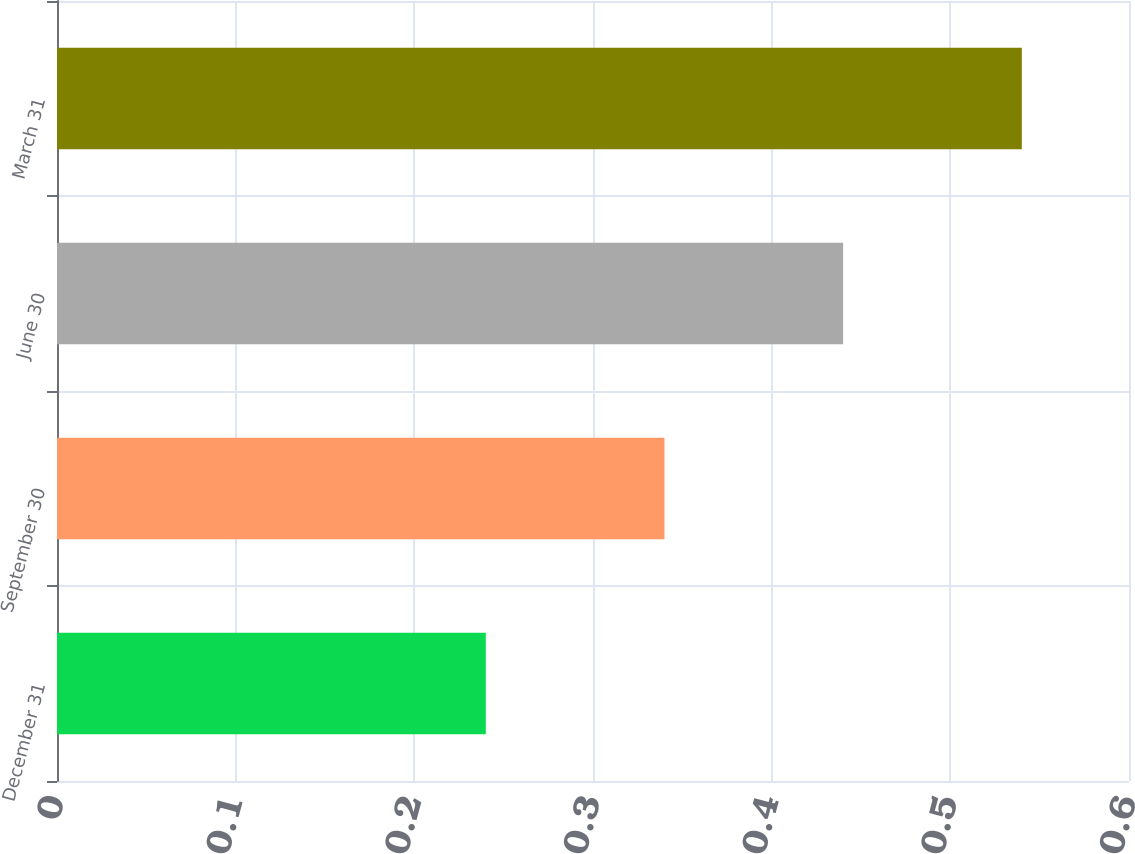<chart> <loc_0><loc_0><loc_500><loc_500><bar_chart><fcel>December 31<fcel>September 30<fcel>June 30<fcel>March 31<nl><fcel>0.24<fcel>0.34<fcel>0.44<fcel>0.54<nl></chart> 